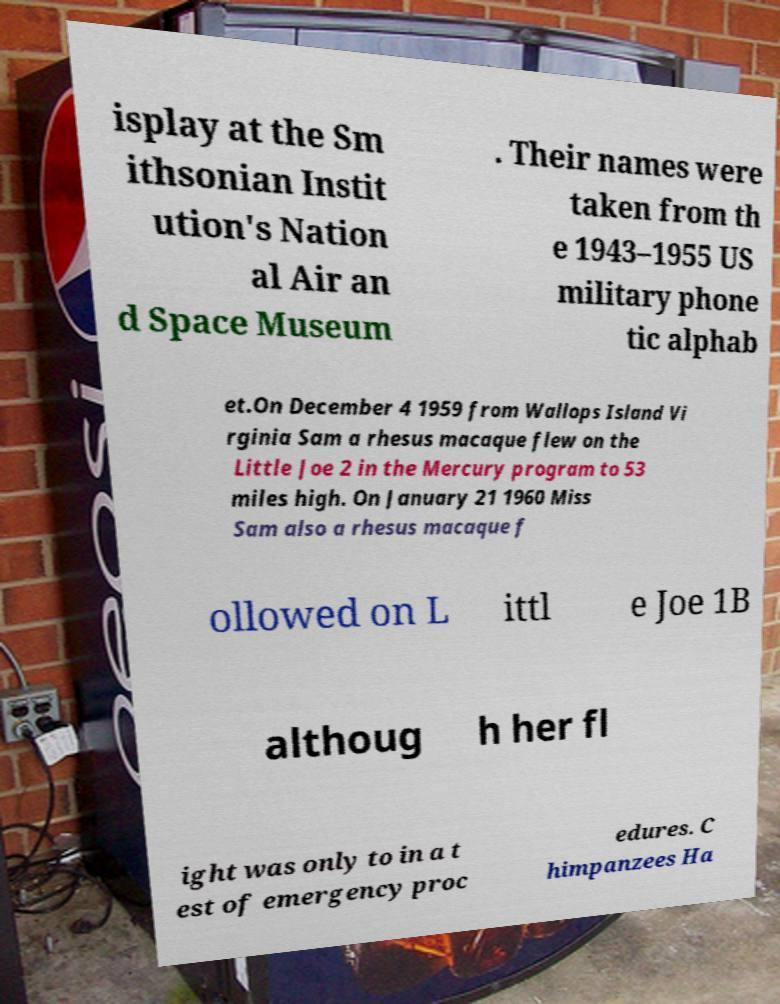What messages or text are displayed in this image? I need them in a readable, typed format. isplay at the Sm ithsonian Instit ution's Nation al Air an d Space Museum . Their names were taken from th e 1943–1955 US military phone tic alphab et.On December 4 1959 from Wallops Island Vi rginia Sam a rhesus macaque flew on the Little Joe 2 in the Mercury program to 53 miles high. On January 21 1960 Miss Sam also a rhesus macaque f ollowed on L ittl e Joe 1B althoug h her fl ight was only to in a t est of emergency proc edures. C himpanzees Ha 